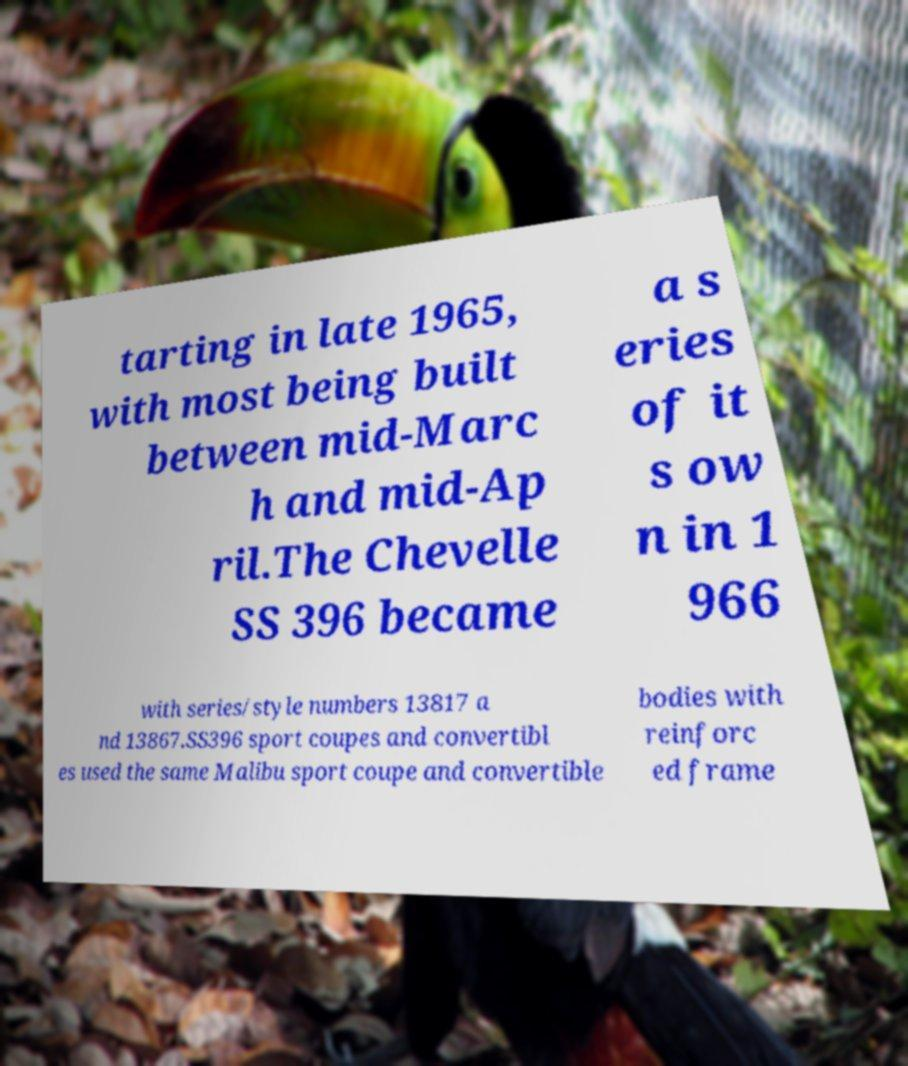Please read and relay the text visible in this image. What does it say? tarting in late 1965, with most being built between mid-Marc h and mid-Ap ril.The Chevelle SS 396 became a s eries of it s ow n in 1 966 with series/style numbers 13817 a nd 13867.SS396 sport coupes and convertibl es used the same Malibu sport coupe and convertible bodies with reinforc ed frame 